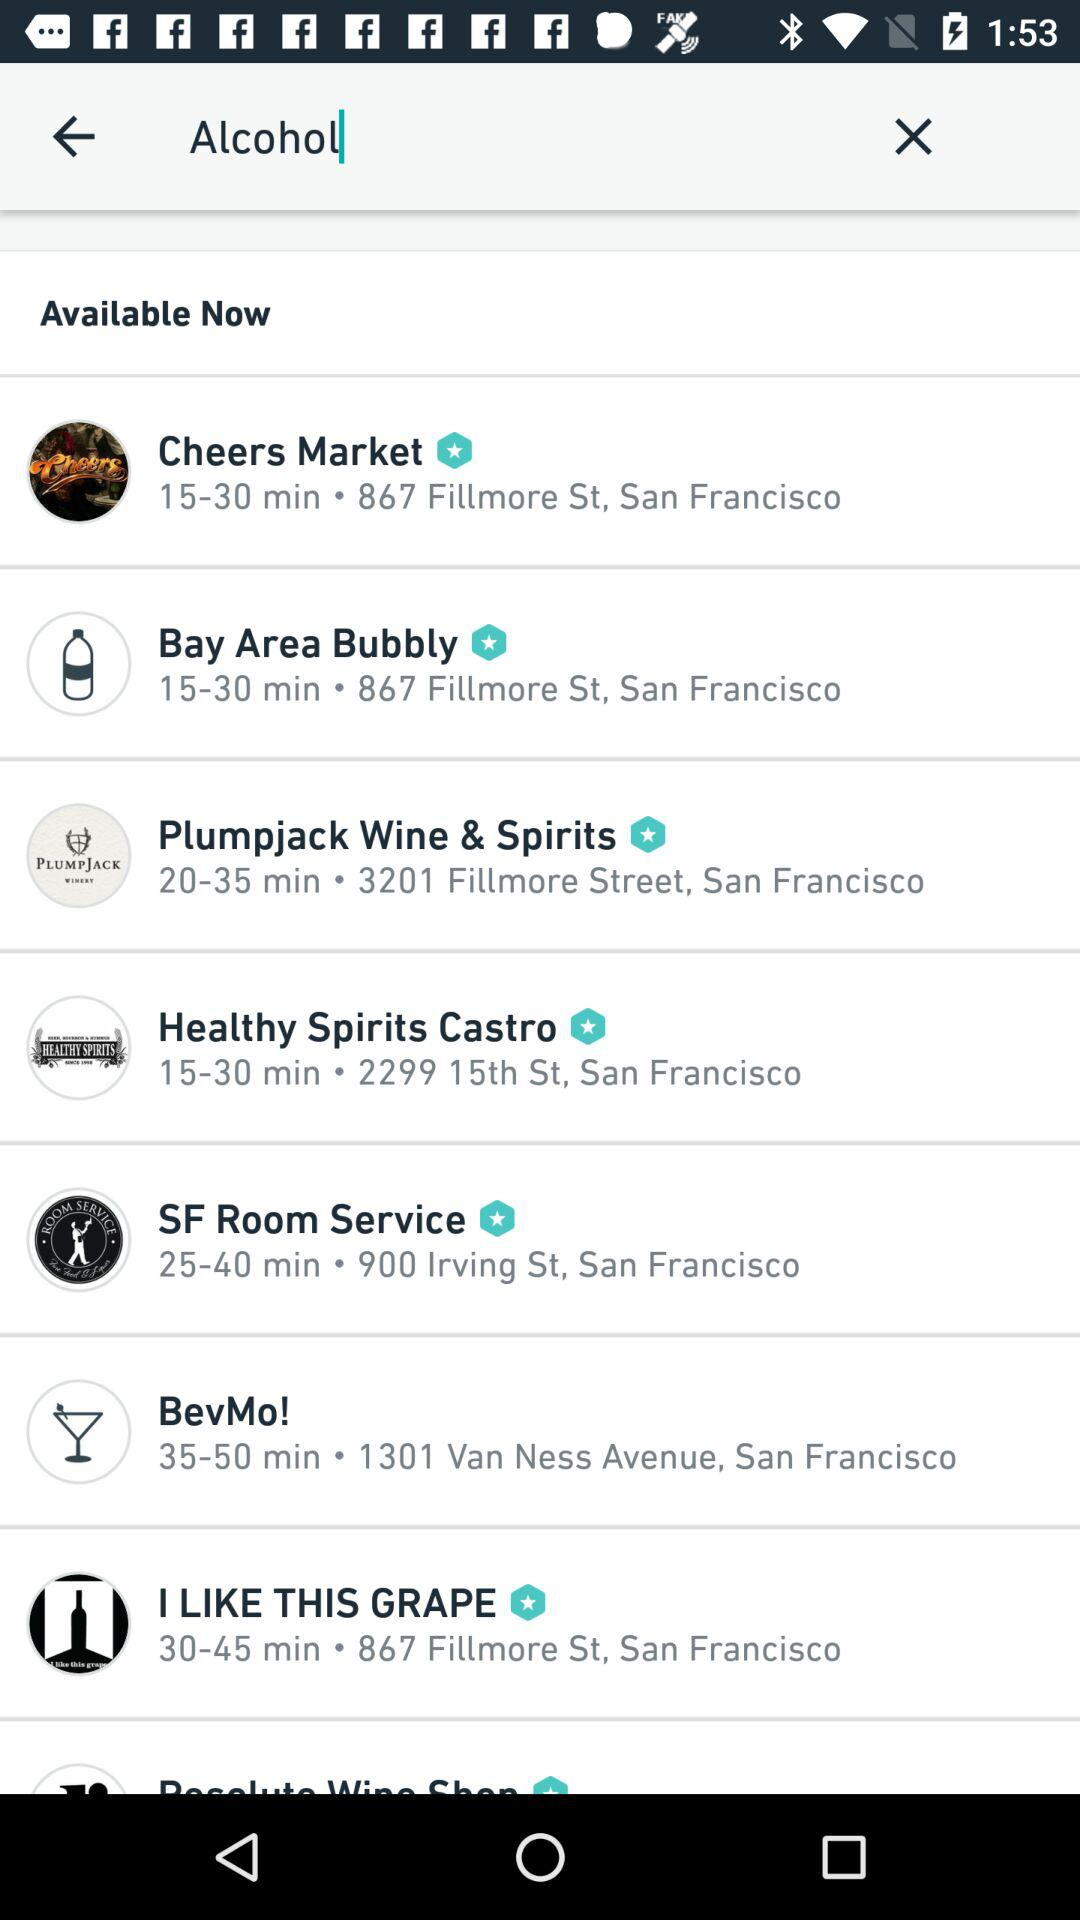How far is the SF Room service?
When the provided information is insufficient, respond with <no answer>. <no answer> 